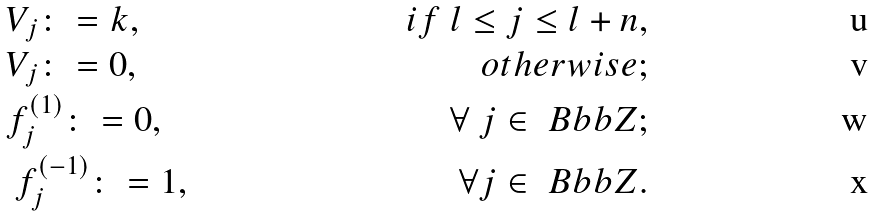Convert formula to latex. <formula><loc_0><loc_0><loc_500><loc_500>& V _ { j } \colon = k , & i f \ l \leq j \leq l + n , \\ & V _ { j } \colon = 0 , & o t h e r w i s e ; \\ & f _ { j } ^ { ( 1 ) } \colon = 0 , & \ \forall \ j \in \ B b b Z ; \\ & \ f _ { j } ^ { ( - 1 ) } \colon = 1 , & \forall j \in \ B b b Z .</formula> 